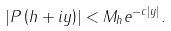Convert formula to latex. <formula><loc_0><loc_0><loc_500><loc_500>\left | P \left ( h + i y \right ) \right | < M _ { h } e ^ { - c \left | y \right | } .</formula> 